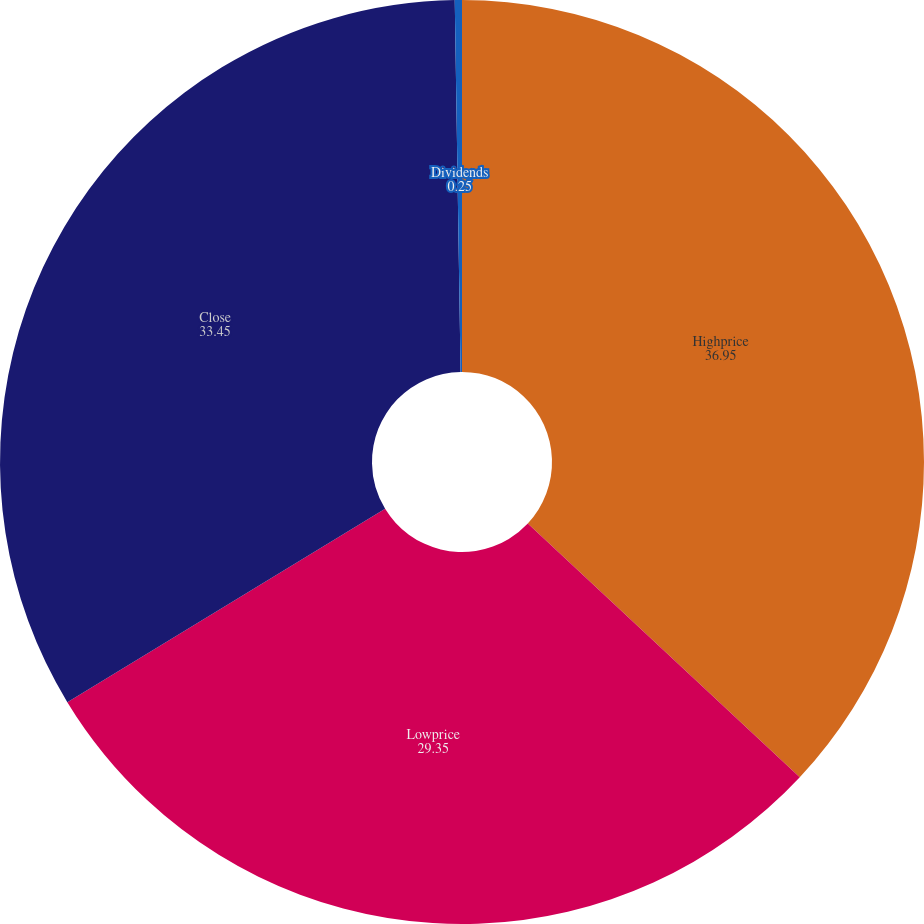Convert chart to OTSL. <chart><loc_0><loc_0><loc_500><loc_500><pie_chart><fcel>Highprice<fcel>Lowprice<fcel>Close<fcel>Dividends<nl><fcel>36.95%<fcel>29.35%<fcel>33.45%<fcel>0.25%<nl></chart> 